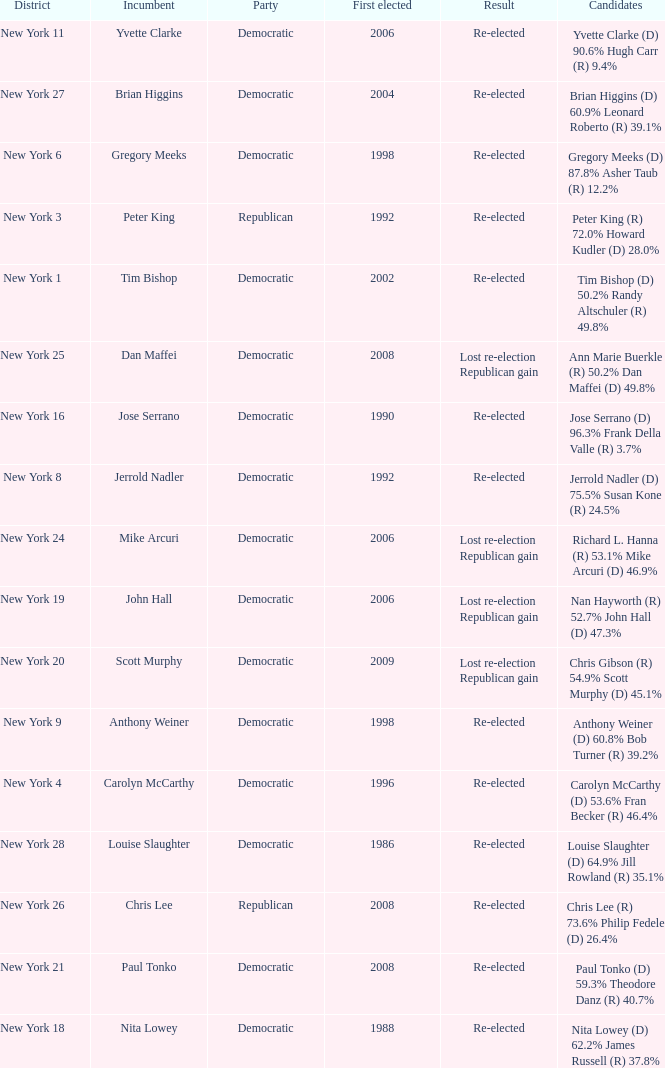Name the number of party for richard l. hanna (r) 53.1% mike arcuri (d) 46.9% 1.0. 